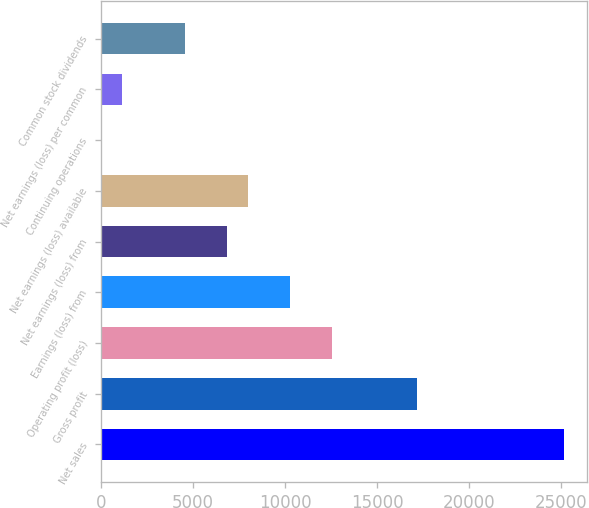Convert chart to OTSL. <chart><loc_0><loc_0><loc_500><loc_500><bar_chart><fcel>Net sales<fcel>Gross profit<fcel>Operating profit (loss)<fcel>Earnings (loss) from<fcel>Net earnings (loss) from<fcel>Net earnings (loss) available<fcel>Continuing operations<fcel>Net earnings (loss) per common<fcel>Common stock dividends<nl><fcel>25149.4<fcel>17147.6<fcel>12575.1<fcel>10288.9<fcel>6859.51<fcel>8002.63<fcel>0.79<fcel>1143.91<fcel>4573.27<nl></chart> 